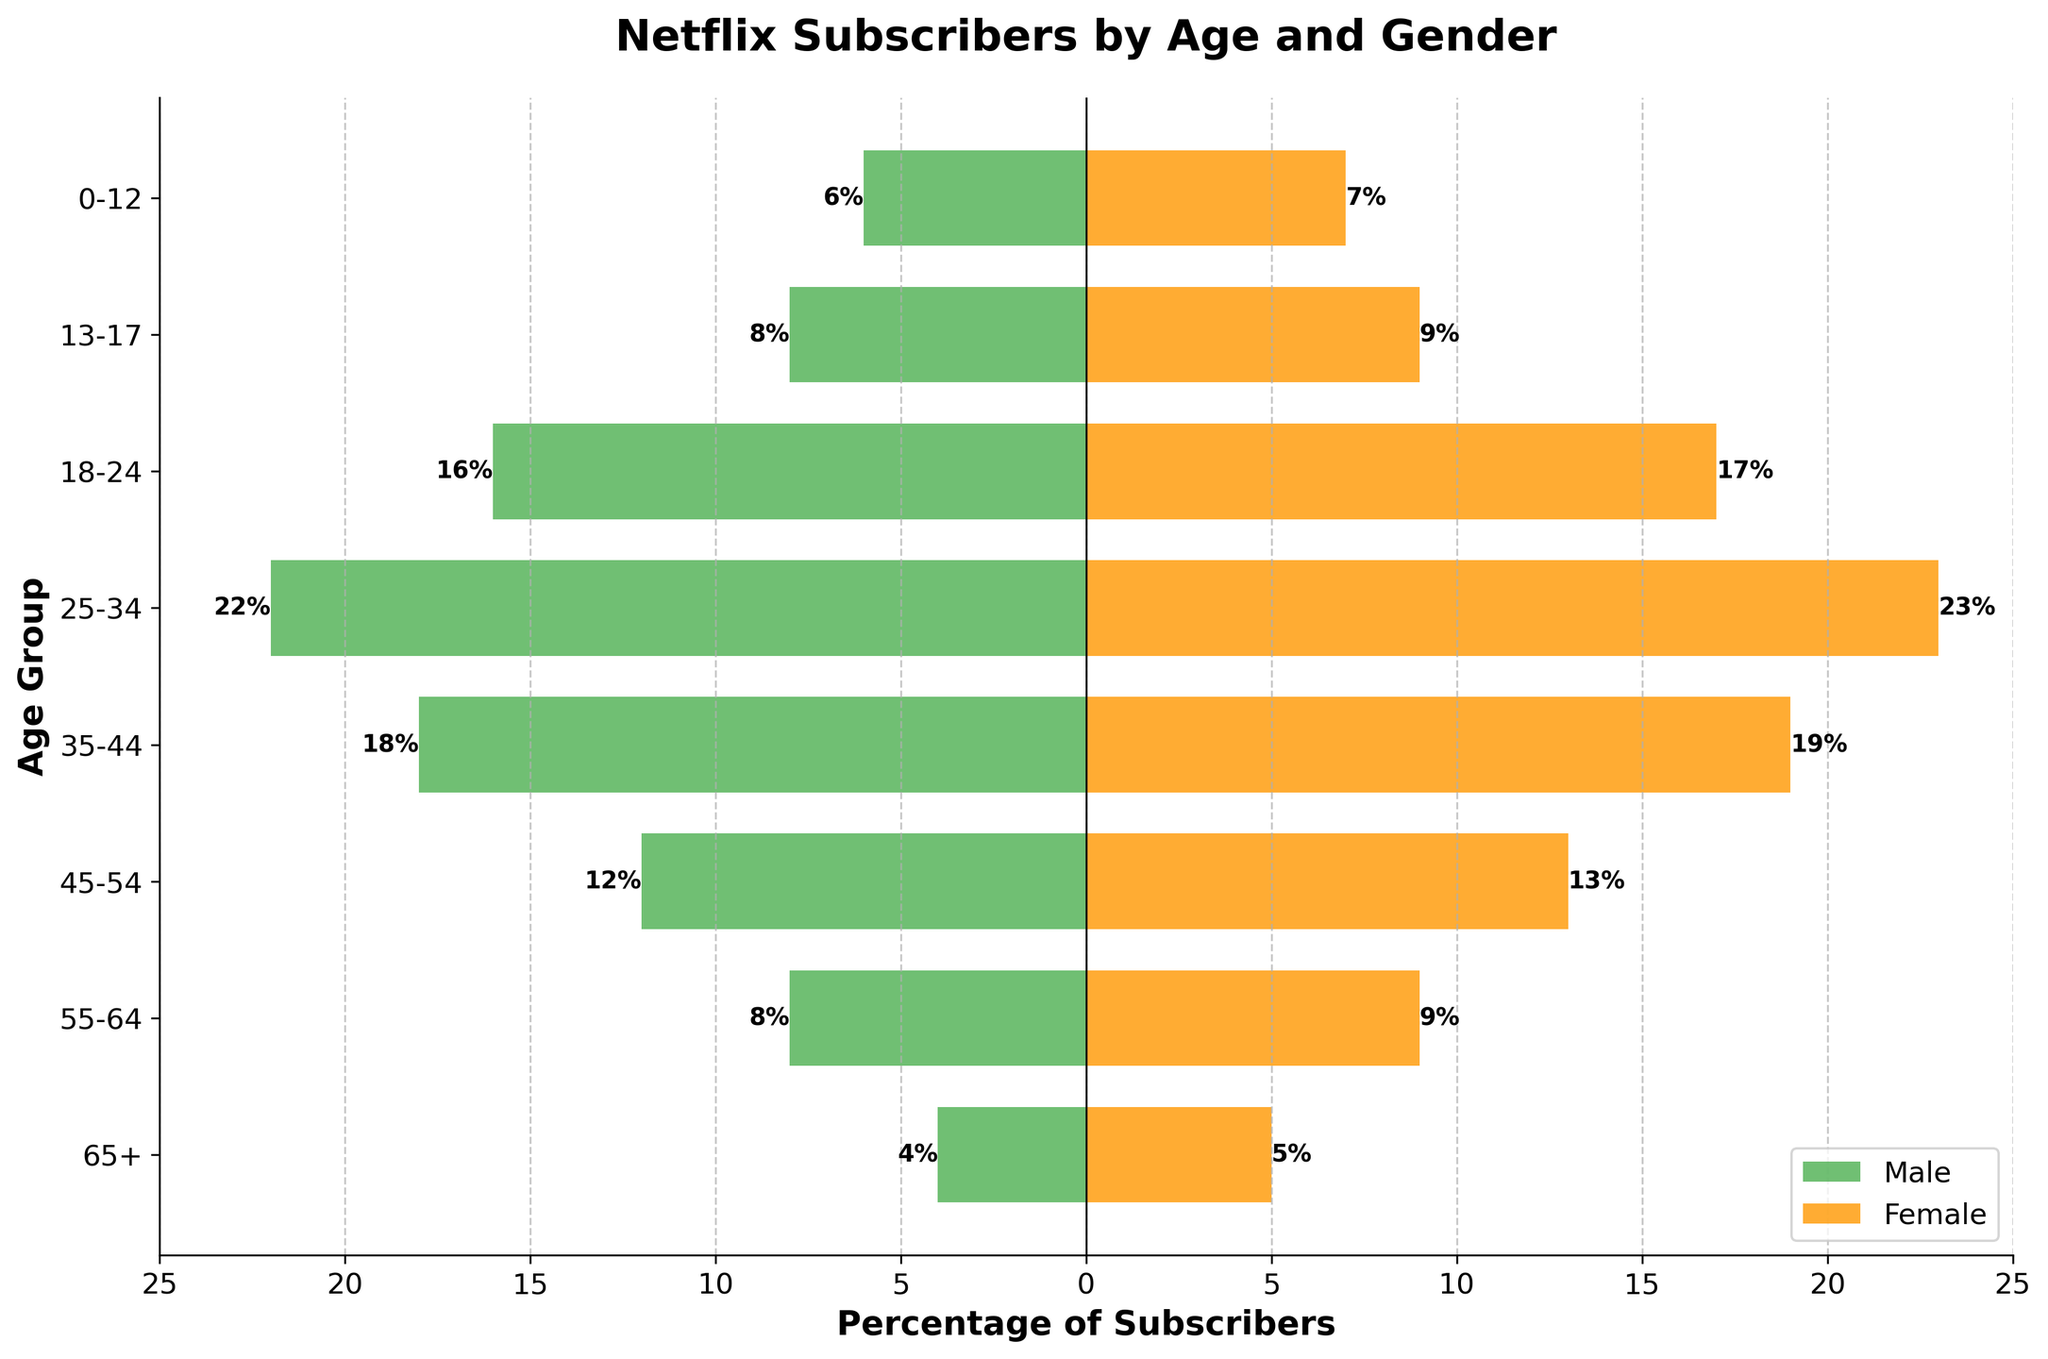What's the title of the figure? The title is usually found at the top of the figure and provides an overview of what the data is about.
Answer: Netflix Subscribers by Age and Gender What is the age group with the highest percentage of male subscribers? Look at the horizontal bars on the left side of the figure, representing male subscribers, and identify the bar that extends the furthest to the left.
Answer: 25-34 Which gender has a higher percentage in the age group 35-44? Compare the lengths of the bars for males and females within the 35-44 age group. The bar that extends further represents the higher percentage.
Answer: Female What is the total percentage of subscribers in the 18-24 age group? Add the lengths of the bars representing male and female subscribers in the 18-24 age group.
Answer: 33% In which age group is the difference between male and female subscribers the largest? Examine the bars for each age group and calculate the absolute difference between the lengths of the male and female bars to find the maximum difference.
Answer: 25-34 Which age group has the lowest percentage of subscribers? Identify the age group with the shortest combined bars for both male and female subscribers.
Answer: 0-12 How many age groups have more female subscribers than male subscribers? Count the age groups where the female bar is longer than the male bar.
Answer: 4 What is the percentage of male subscribers in the 55-64 age group? Refer to the length of the bar representing male subscribers in the 55-64 age group. The label at the end of the bar indicates the percentage.
Answer: 8% How does the percentage of female subscribers in the 13-17 age group compare to that in the 45-54 age group? Compare the lengths of the bars for female subscribers in the 13-17 and 45-54 age groups to determine which is longer.
Answer: The 45-54 age group has a higher percentage of female subscribers What is the difference in percentage between male and female subscribers in the 65+ age group? Calculate the absolute difference between the lengths of the bars for male and female subscribers in the 65+ age group.
Answer: 1% 